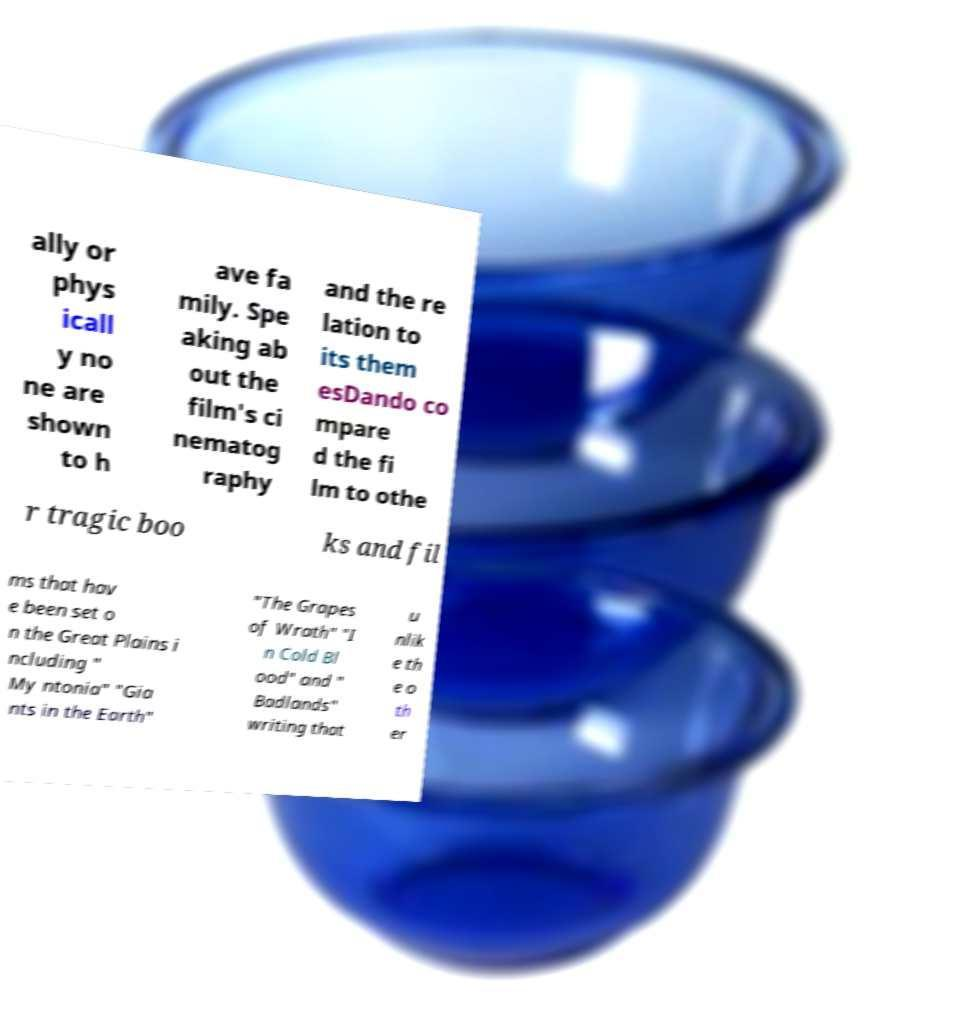Please identify and transcribe the text found in this image. ally or phys icall y no ne are shown to h ave fa mily. Spe aking ab out the film's ci nematog raphy and the re lation to its them esDando co mpare d the fi lm to othe r tragic boo ks and fil ms that hav e been set o n the Great Plains i ncluding " My ntonia" "Gia nts in the Earth" "The Grapes of Wrath" "I n Cold Bl ood" and " Badlands" writing that u nlik e th e o th er 